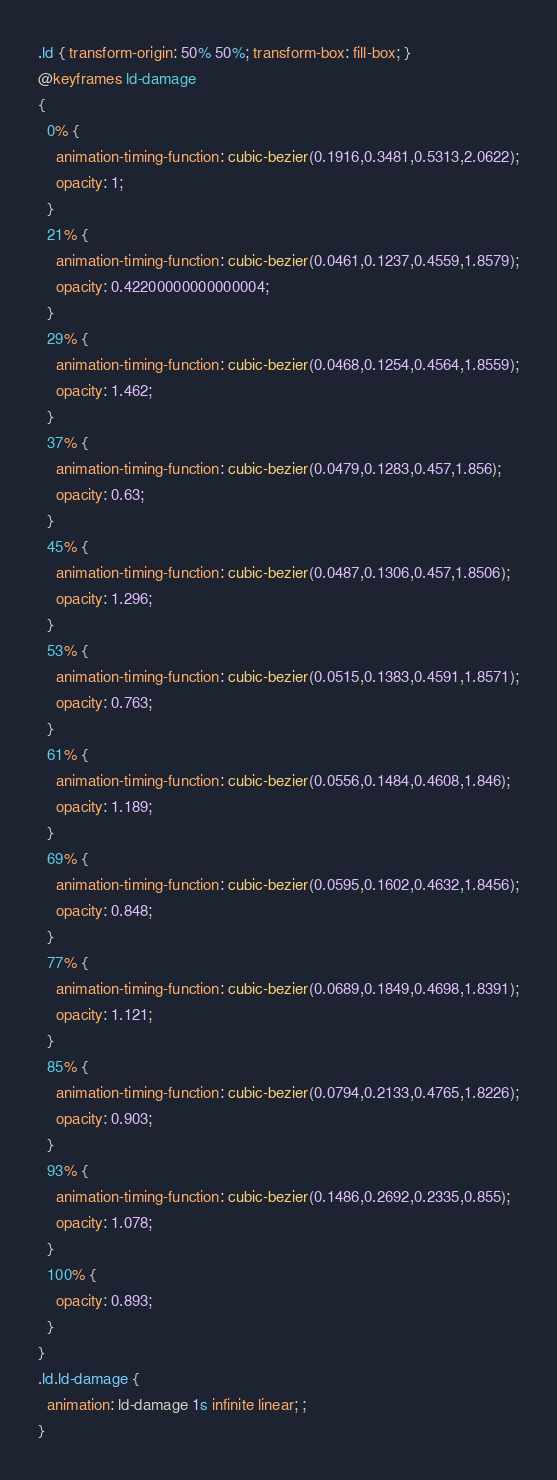Convert code to text. <code><loc_0><loc_0><loc_500><loc_500><_CSS_>.ld { transform-origin: 50% 50%; transform-box: fill-box; }
@keyframes ld-damage
{
  0% {
    animation-timing-function: cubic-bezier(0.1916,0.3481,0.5313,2.0622);
    opacity: 1;
  }
  21% {
    animation-timing-function: cubic-bezier(0.0461,0.1237,0.4559,1.8579);
    opacity: 0.42200000000000004;
  }
  29% {
    animation-timing-function: cubic-bezier(0.0468,0.1254,0.4564,1.8559);
    opacity: 1.462;
  }
  37% {
    animation-timing-function: cubic-bezier(0.0479,0.1283,0.457,1.856);
    opacity: 0.63;
  }
  45% {
    animation-timing-function: cubic-bezier(0.0487,0.1306,0.457,1.8506);
    opacity: 1.296;
  }
  53% {
    animation-timing-function: cubic-bezier(0.0515,0.1383,0.4591,1.8571);
    opacity: 0.763;
  }
  61% {
    animation-timing-function: cubic-bezier(0.0556,0.1484,0.4608,1.846);
    opacity: 1.189;
  }
  69% {
    animation-timing-function: cubic-bezier(0.0595,0.1602,0.4632,1.8456);
    opacity: 0.848;
  }
  77% {
    animation-timing-function: cubic-bezier(0.0689,0.1849,0.4698,1.8391);
    opacity: 1.121;
  }
  85% {
    animation-timing-function: cubic-bezier(0.0794,0.2133,0.4765,1.8226);
    opacity: 0.903;
  }
  93% {
    animation-timing-function: cubic-bezier(0.1486,0.2692,0.2335,0.855);
    opacity: 1.078;
  }
  100% {
    opacity: 0.893;
  }
}
.ld.ld-damage {
  animation: ld-damage 1s infinite linear; ; 
}</code> 